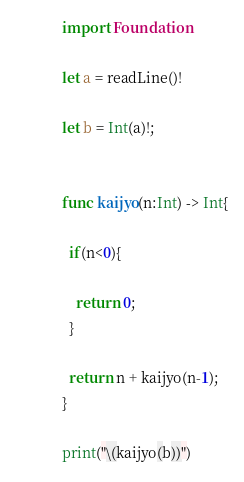Convert code to text. <code><loc_0><loc_0><loc_500><loc_500><_Swift_>import Foundation

let a = readLine()!

let b = Int(a)!;


func kaijyo(n:Int) -> Int{
 
  if(n<0){
   
    return 0;
  }
  
  return n + kaijyo(n-1);
}

print("\(kaijyo(b))")</code> 